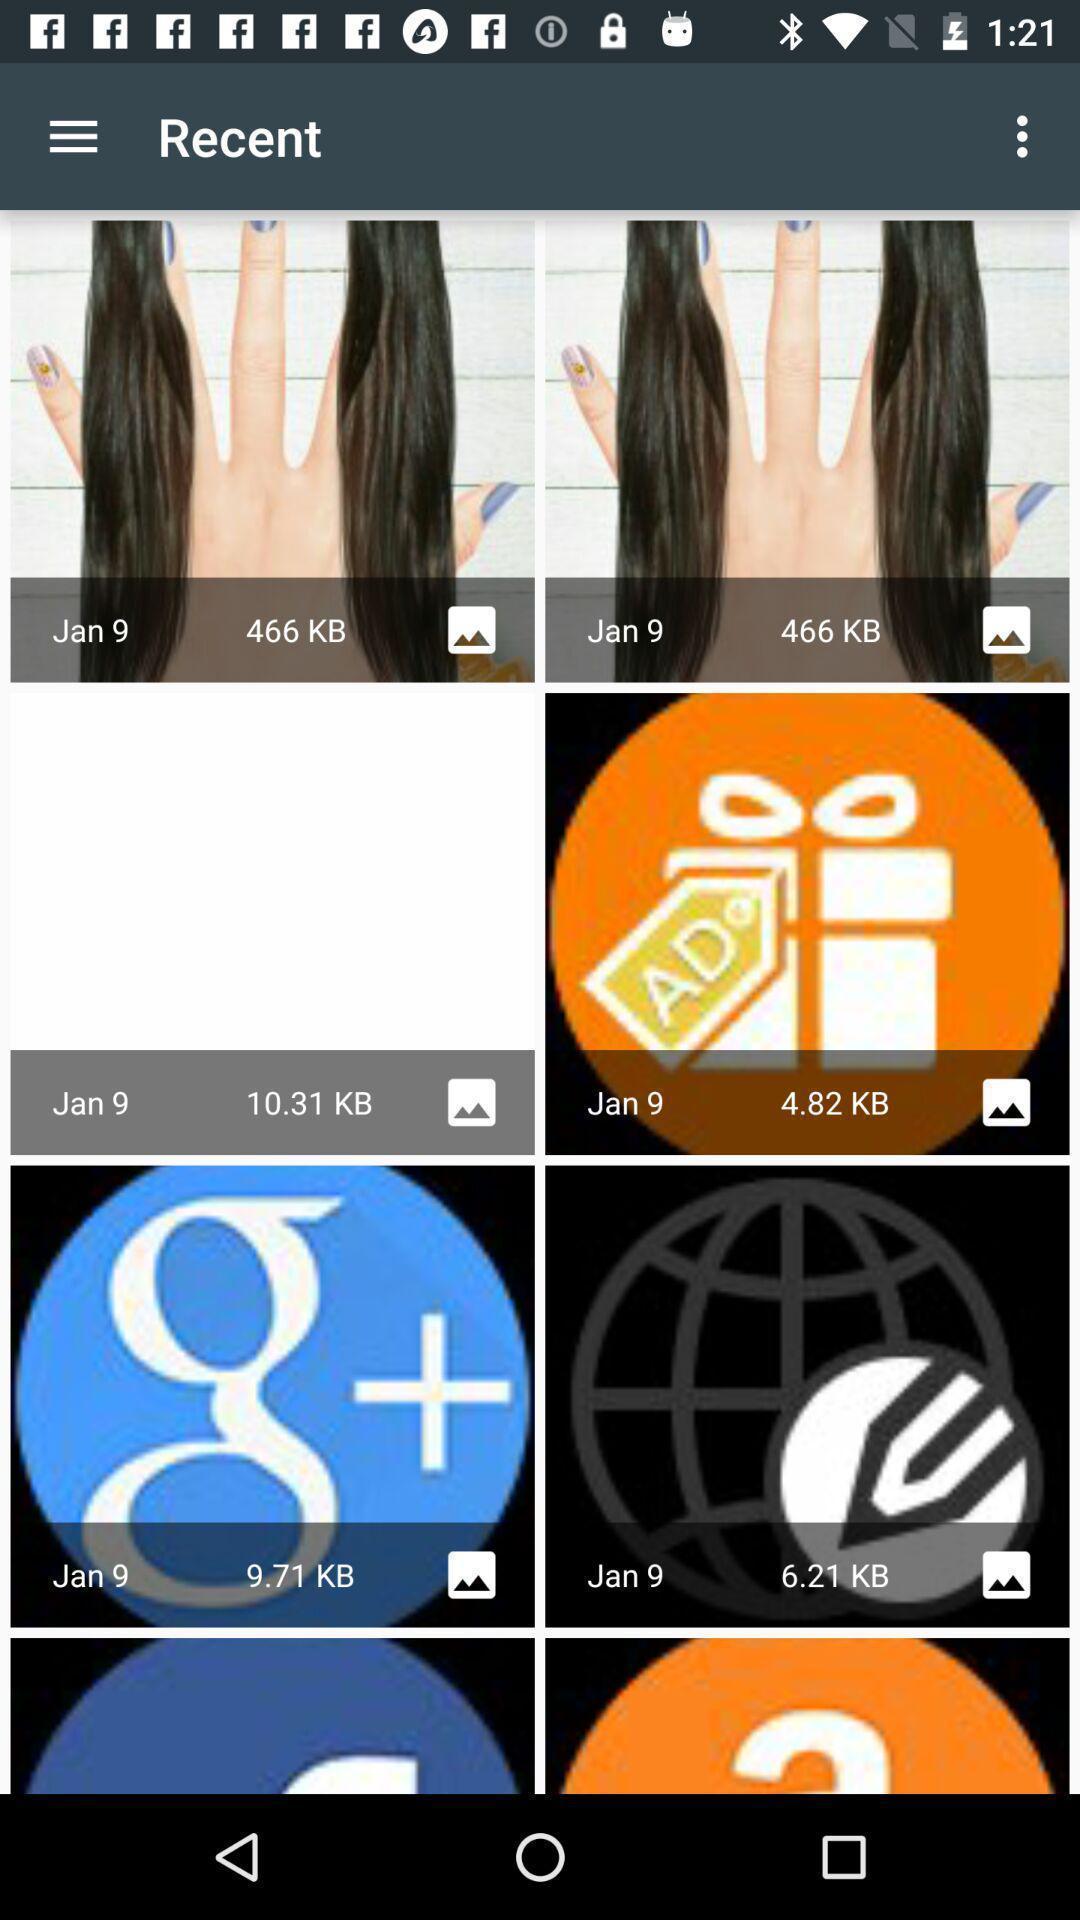What is the overall content of this screenshot? Screen showing recent images page. 